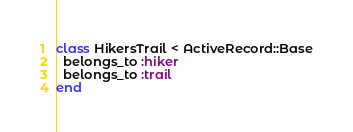Convert code to text. <code><loc_0><loc_0><loc_500><loc_500><_Ruby_>class HikersTrail < ActiveRecord::Base
  belongs_to :hiker
  belongs_to :trail
end</code> 